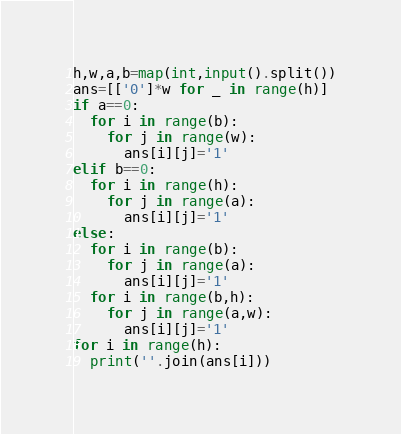<code> <loc_0><loc_0><loc_500><loc_500><_Python_>h,w,a,b=map(int,input().split())
ans=[['0']*w for _ in range(h)]
if a==0:
  for i in range(b):
    for j in range(w):
      ans[i][j]='1'
elif b==0:
  for i in range(h):
    for j in range(a):
      ans[i][j]='1'
else:
  for i in range(b):
    for j in range(a):
      ans[i][j]='1'
  for i in range(b,h):
    for j in range(a,w):
      ans[i][j]='1'
for i in range(h):
  print(''.join(ans[i]))</code> 